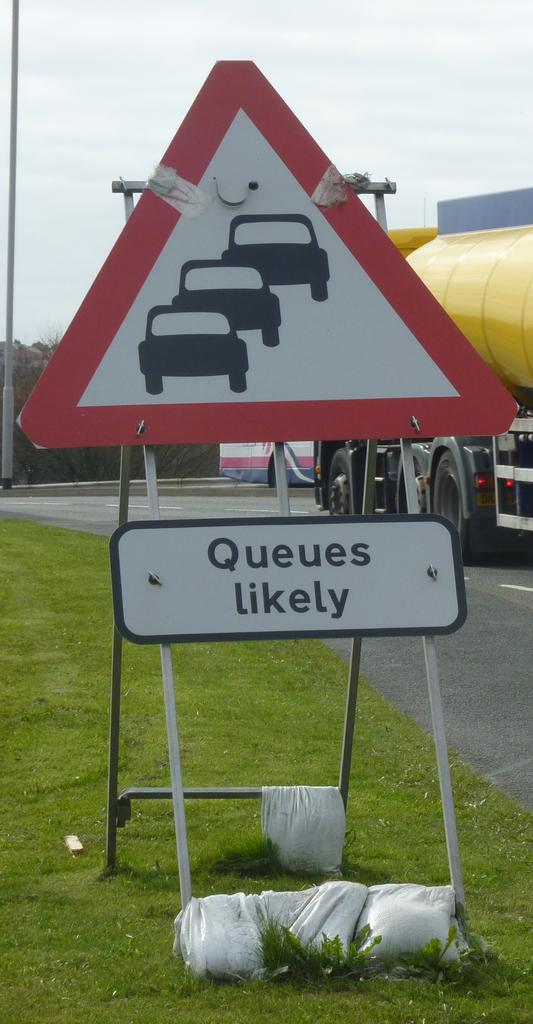<image>
Present a compact description of the photo's key features. A road sign letting motorists know that queues are likely. 